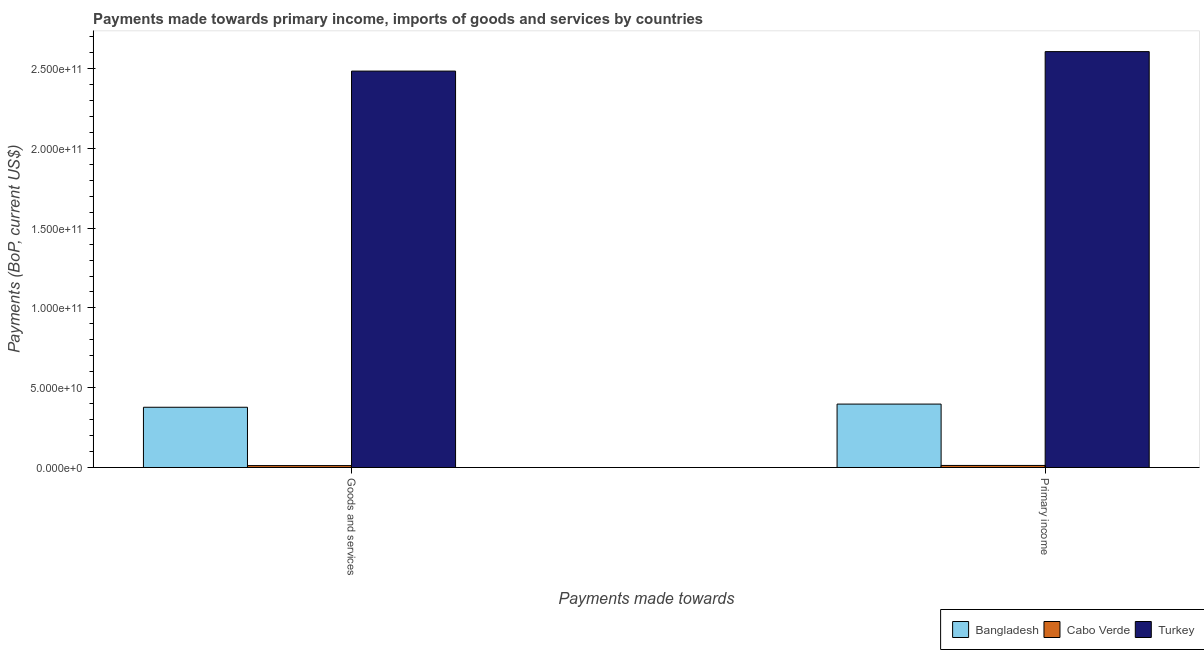How many different coloured bars are there?
Give a very brief answer. 3. Are the number of bars per tick equal to the number of legend labels?
Provide a short and direct response. Yes. How many bars are there on the 1st tick from the right?
Your answer should be compact. 3. What is the label of the 1st group of bars from the left?
Your response must be concise. Goods and services. What is the payments made towards primary income in Cabo Verde?
Make the answer very short. 1.28e+09. Across all countries, what is the maximum payments made towards primary income?
Offer a terse response. 2.61e+11. Across all countries, what is the minimum payments made towards primary income?
Keep it short and to the point. 1.28e+09. In which country was the payments made towards primary income minimum?
Ensure brevity in your answer.  Cabo Verde. What is the total payments made towards primary income in the graph?
Offer a terse response. 3.02e+11. What is the difference between the payments made towards primary income in Turkey and that in Cabo Verde?
Provide a succinct answer. 2.59e+11. What is the difference between the payments made towards primary income in Bangladesh and the payments made towards goods and services in Turkey?
Your answer should be very brief. -2.09e+11. What is the average payments made towards primary income per country?
Ensure brevity in your answer.  1.01e+11. What is the difference between the payments made towards goods and services and payments made towards primary income in Bangladesh?
Provide a succinct answer. -1.99e+09. What is the ratio of the payments made towards primary income in Cabo Verde to that in Bangladesh?
Your answer should be compact. 0.03. What does the 2nd bar from the left in Primary income represents?
Offer a very short reply. Cabo Verde. How many bars are there?
Provide a short and direct response. 6. Does the graph contain any zero values?
Your answer should be very brief. No. Does the graph contain grids?
Ensure brevity in your answer.  No. How are the legend labels stacked?
Offer a terse response. Horizontal. What is the title of the graph?
Provide a short and direct response. Payments made towards primary income, imports of goods and services by countries. Does "Cyprus" appear as one of the legend labels in the graph?
Your answer should be compact. No. What is the label or title of the X-axis?
Keep it short and to the point. Payments made towards. What is the label or title of the Y-axis?
Your answer should be compact. Payments (BoP, current US$). What is the Payments (BoP, current US$) of Bangladesh in Goods and services?
Ensure brevity in your answer.  3.77e+1. What is the Payments (BoP, current US$) in Cabo Verde in Goods and services?
Your answer should be compact. 1.19e+09. What is the Payments (BoP, current US$) in Turkey in Goods and services?
Provide a short and direct response. 2.48e+11. What is the Payments (BoP, current US$) in Bangladesh in Primary income?
Provide a succinct answer. 3.97e+1. What is the Payments (BoP, current US$) of Cabo Verde in Primary income?
Offer a terse response. 1.28e+09. What is the Payments (BoP, current US$) in Turkey in Primary income?
Provide a succinct answer. 2.61e+11. Across all Payments made towards, what is the maximum Payments (BoP, current US$) in Bangladesh?
Your answer should be very brief. 3.97e+1. Across all Payments made towards, what is the maximum Payments (BoP, current US$) of Cabo Verde?
Make the answer very short. 1.28e+09. Across all Payments made towards, what is the maximum Payments (BoP, current US$) of Turkey?
Provide a short and direct response. 2.61e+11. Across all Payments made towards, what is the minimum Payments (BoP, current US$) of Bangladesh?
Give a very brief answer. 3.77e+1. Across all Payments made towards, what is the minimum Payments (BoP, current US$) in Cabo Verde?
Your response must be concise. 1.19e+09. Across all Payments made towards, what is the minimum Payments (BoP, current US$) in Turkey?
Offer a very short reply. 2.48e+11. What is the total Payments (BoP, current US$) of Bangladesh in the graph?
Offer a terse response. 7.75e+1. What is the total Payments (BoP, current US$) in Cabo Verde in the graph?
Ensure brevity in your answer.  2.46e+09. What is the total Payments (BoP, current US$) in Turkey in the graph?
Provide a succinct answer. 5.09e+11. What is the difference between the Payments (BoP, current US$) in Bangladesh in Goods and services and that in Primary income?
Offer a very short reply. -1.99e+09. What is the difference between the Payments (BoP, current US$) in Cabo Verde in Goods and services and that in Primary income?
Provide a succinct answer. -8.77e+07. What is the difference between the Payments (BoP, current US$) of Turkey in Goods and services and that in Primary income?
Ensure brevity in your answer.  -1.22e+1. What is the difference between the Payments (BoP, current US$) of Bangladesh in Goods and services and the Payments (BoP, current US$) of Cabo Verde in Primary income?
Your answer should be compact. 3.65e+1. What is the difference between the Payments (BoP, current US$) in Bangladesh in Goods and services and the Payments (BoP, current US$) in Turkey in Primary income?
Your answer should be compact. -2.23e+11. What is the difference between the Payments (BoP, current US$) in Cabo Verde in Goods and services and the Payments (BoP, current US$) in Turkey in Primary income?
Give a very brief answer. -2.59e+11. What is the average Payments (BoP, current US$) of Bangladesh per Payments made towards?
Give a very brief answer. 3.87e+1. What is the average Payments (BoP, current US$) in Cabo Verde per Payments made towards?
Ensure brevity in your answer.  1.23e+09. What is the average Payments (BoP, current US$) in Turkey per Payments made towards?
Give a very brief answer. 2.55e+11. What is the difference between the Payments (BoP, current US$) of Bangladesh and Payments (BoP, current US$) of Cabo Verde in Goods and services?
Give a very brief answer. 3.66e+1. What is the difference between the Payments (BoP, current US$) in Bangladesh and Payments (BoP, current US$) in Turkey in Goods and services?
Give a very brief answer. -2.11e+11. What is the difference between the Payments (BoP, current US$) in Cabo Verde and Payments (BoP, current US$) in Turkey in Goods and services?
Offer a very short reply. -2.47e+11. What is the difference between the Payments (BoP, current US$) in Bangladesh and Payments (BoP, current US$) in Cabo Verde in Primary income?
Provide a succinct answer. 3.85e+1. What is the difference between the Payments (BoP, current US$) of Bangladesh and Payments (BoP, current US$) of Turkey in Primary income?
Provide a succinct answer. -2.21e+11. What is the difference between the Payments (BoP, current US$) of Cabo Verde and Payments (BoP, current US$) of Turkey in Primary income?
Your response must be concise. -2.59e+11. What is the ratio of the Payments (BoP, current US$) of Bangladesh in Goods and services to that in Primary income?
Keep it short and to the point. 0.95. What is the ratio of the Payments (BoP, current US$) of Cabo Verde in Goods and services to that in Primary income?
Ensure brevity in your answer.  0.93. What is the ratio of the Payments (BoP, current US$) in Turkey in Goods and services to that in Primary income?
Give a very brief answer. 0.95. What is the difference between the highest and the second highest Payments (BoP, current US$) of Bangladesh?
Provide a succinct answer. 1.99e+09. What is the difference between the highest and the second highest Payments (BoP, current US$) of Cabo Verde?
Keep it short and to the point. 8.77e+07. What is the difference between the highest and the second highest Payments (BoP, current US$) in Turkey?
Keep it short and to the point. 1.22e+1. What is the difference between the highest and the lowest Payments (BoP, current US$) of Bangladesh?
Your answer should be very brief. 1.99e+09. What is the difference between the highest and the lowest Payments (BoP, current US$) in Cabo Verde?
Your response must be concise. 8.77e+07. What is the difference between the highest and the lowest Payments (BoP, current US$) in Turkey?
Provide a short and direct response. 1.22e+1. 